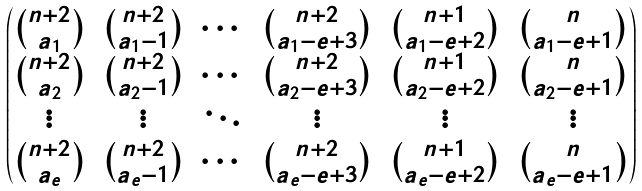Convert formula to latex. <formula><loc_0><loc_0><loc_500><loc_500>\begin{pmatrix} \binom { n + 2 } { a _ { 1 } } & \binom { n + 2 } { a _ { 1 } - 1 } & \cdots & \binom { n + 2 } { a _ { 1 } - e + 3 } & \binom { n + 1 } { a _ { 1 } - e + 2 } & \binom { n } { a _ { 1 } - e + 1 } \\ \binom { n + 2 } { a _ { 2 } } & \binom { n + 2 } { a _ { 2 } - 1 } & \cdots & \binom { n + 2 } { a _ { 2 } - e + 3 } & \binom { n + 1 } { a _ { 2 } - e + 2 } & \binom { n } { a _ { 2 } - e + 1 } \\ \vdots & \vdots & \ddots & \vdots & \vdots & \vdots \\ \binom { n + 2 } { a _ { e } } & \binom { n + 2 } { a _ { e } - 1 } & \cdots & \binom { n + 2 } { a _ { e } - e + 3 } & \binom { n + 1 } { a _ { e } - e + 2 } & \binom { n } { a _ { e } - e + 1 } \end{pmatrix}</formula> 